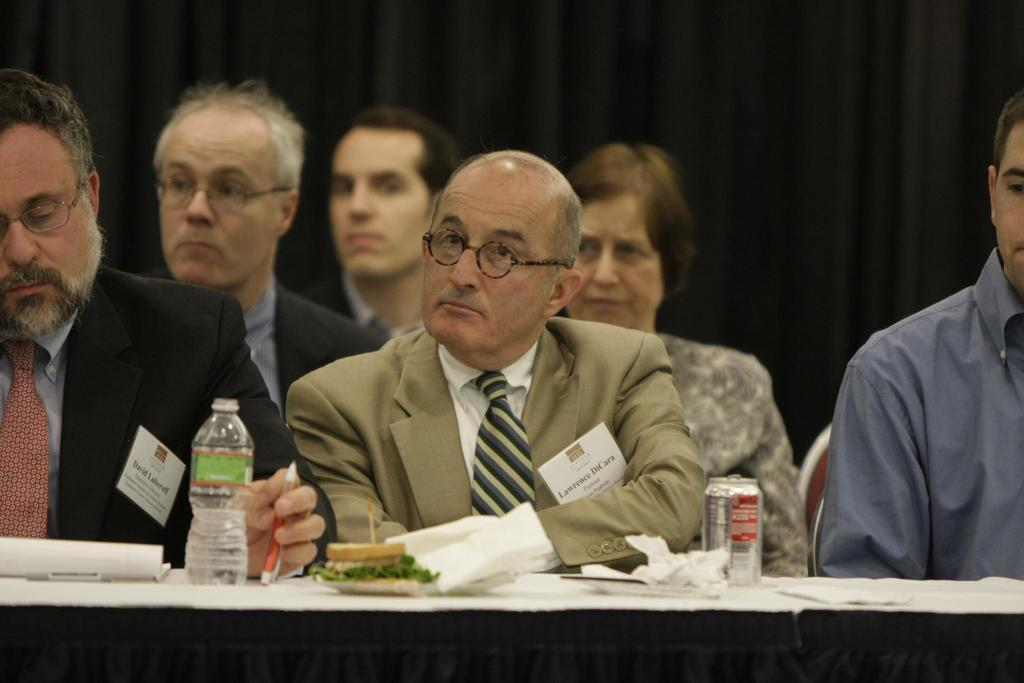What is the main subject of the image? The main subject of the image is a group of people. What are the people in the image doing? The people are seated on chairs. What else can be seen in the image besides the people? There is food visible in the image, as well as a water bottle and a can on the table. What type of watch is the person wearing in the image? There is no watch visible in the image. What kind of arch can be seen in the background of the image? There is no arch present in the image. 